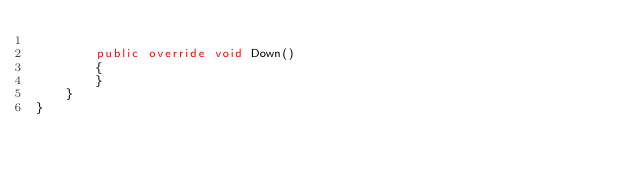<code> <loc_0><loc_0><loc_500><loc_500><_C#_>        
        public override void Down()
        {
        }
    }
}
</code> 